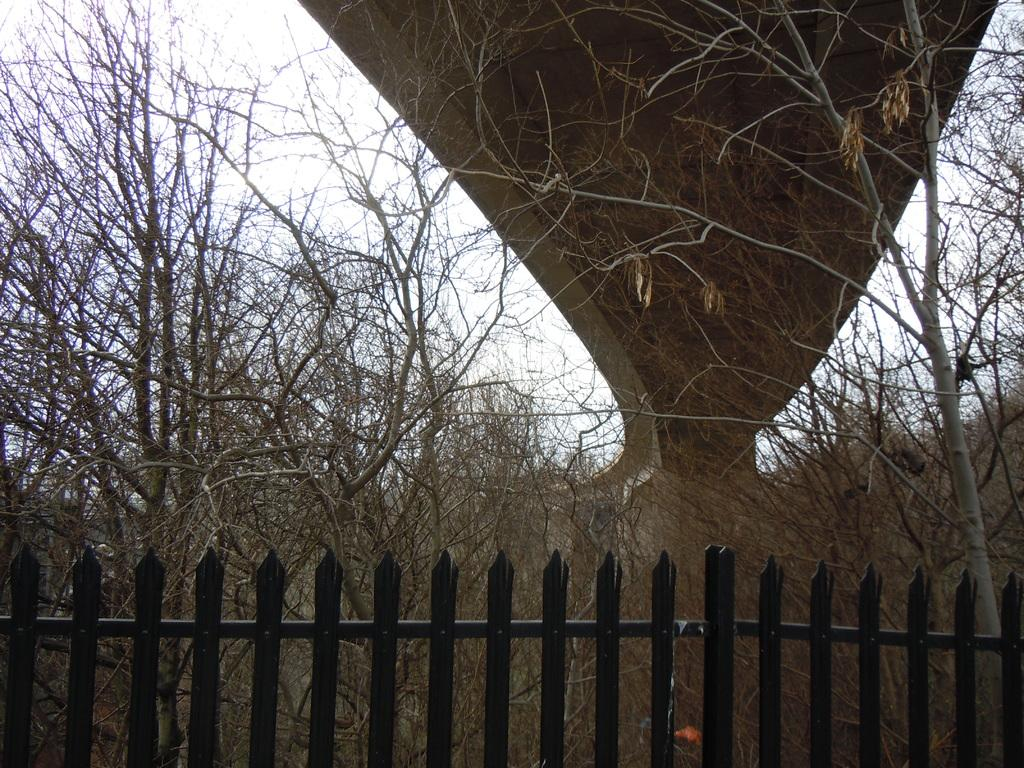What type of structure can be seen in the image? There is a fence in the image. What other natural elements are present in the image? There are trees in the image. What man-made structure is positioned over the trees? There is a bridge in the image, and it is positioned over the trees. What is visible at the top of the image? The sky is visible at the top of the image. What type of feast is being prepared on the bridge in the image? There is no indication of a feast or any food preparation in the image; it only features a bridge positioned over trees. What type of alarm is ringing in the image? There is no alarm present in the image; it only features a bridge, trees, and a fence. 